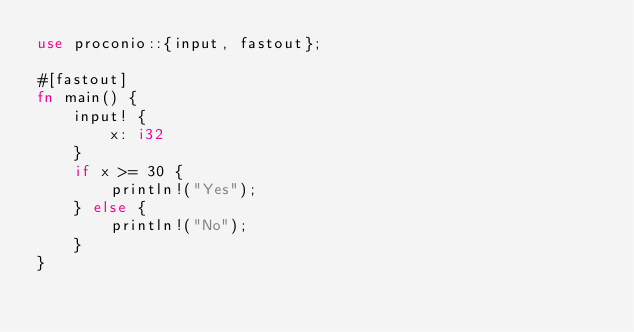<code> <loc_0><loc_0><loc_500><loc_500><_Rust_>use proconio::{input, fastout};

#[fastout]
fn main() {
    input! {
        x: i32 
    }
    if x >= 30 {
        println!("Yes");
    } else {
        println!("No");
    }
}
</code> 